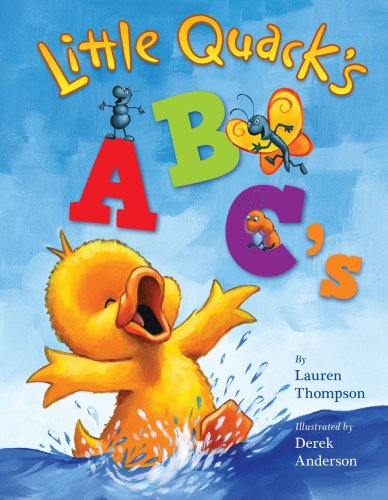What is the title of this book? The title of this vibrant and colorful children's book is 'Little Quack's ABC's,' illustrated by Derek Anderson. 